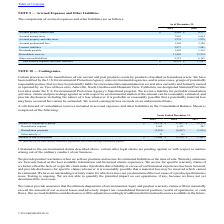From Cts Corporation's financial document, Which years does the table provide information for A roll-forward of remediation reserves included in accrued expenses and other liabilities in the Consolidated Balance Sheets? The document contains multiple relevant values: 2019, 2018, 2017. From the document: "2019 2018 2017 2019 2018 2017 2019 2018 2017..." Also, What did Other activity include? currency translation adjustments not recorded through remediation expense. The document states: "(1) Other activity includes currency translation adjustments not recorded through remediation expense..." Also, What were the Remediation payments in 2017? According to the financial document, (1,416) (in thousands). The relevant text states: "Remediation payments (2,455) (6,967) (1,416)..." Also, How many years did Remediation expense exceed $1,000 thousand? Counting the relevant items in the document: 2019, 2018, I find 2 instances. The key data points involved are: 2018, 2019. Also, can you calculate: What was the change in Other activity between 2018 and 2019? Based on the calculation: 23-(-8), the result is 31 (in thousands). This is based on the information: "Other activity (1) 23 (8) — Other activity (1) 23 (8) —..." The key data points involved are: 23, 8. Also, can you calculate: What was the percentage change in the Balance at end of the period between 2018 and 2019? To answer this question, I need to perform calculations using the financial data. The calculation is: (11,444-11,274)/11,274, which equals 1.51 (percentage). This is based on the information: "Remediation reserves 11,444 11,274 Remediation reserves 11,444 11,274..." The key data points involved are: 11,274, 11,444. 